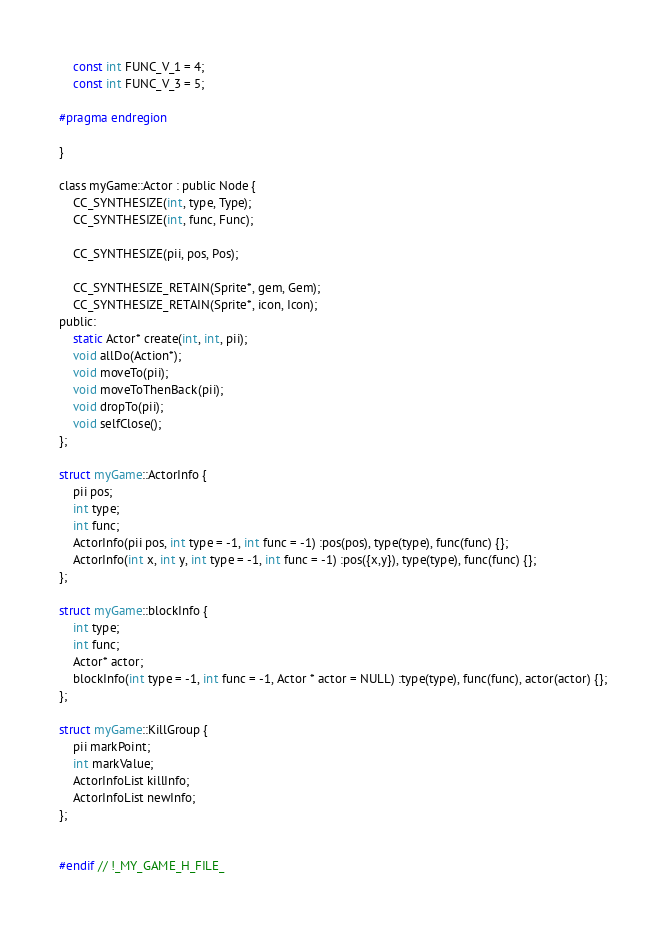Convert code to text. <code><loc_0><loc_0><loc_500><loc_500><_C_>	const int FUNC_V_1 = 4;
	const int FUNC_V_3 = 5;

#pragma endregion

}

class myGame::Actor : public Node {
	CC_SYNTHESIZE(int, type, Type);
	CC_SYNTHESIZE(int, func, Func);

	CC_SYNTHESIZE(pii, pos, Pos);

	CC_SYNTHESIZE_RETAIN(Sprite*, gem, Gem);
	CC_SYNTHESIZE_RETAIN(Sprite*, icon, Icon);
public:
	static Actor* create(int, int, pii);
	void allDo(Action*);
	void moveTo(pii);
	void moveToThenBack(pii);
	void dropTo(pii);
	void selfClose();
};

struct myGame::ActorInfo {
	pii pos;
	int type;
	int func;
	ActorInfo(pii pos, int type = -1, int func = -1) :pos(pos), type(type), func(func) {};
	ActorInfo(int x, int y, int type = -1, int func = -1) :pos({x,y}), type(type), func(func) {};
};

struct myGame::blockInfo {
	int type;
	int func;
	Actor* actor;
	blockInfo(int type = -1, int func = -1, Actor * actor = NULL) :type(type), func(func), actor(actor) {};
};

struct myGame::KillGroup {
	pii markPoint;
	int markValue;
	ActorInfoList killInfo;
	ActorInfoList newInfo;
};


#endif // !_MY_GAME_H_FILE_
</code> 